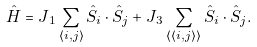<formula> <loc_0><loc_0><loc_500><loc_500>\hat { H } = J { _ { 1 } } \sum _ { \langle i , j \rangle } \hat { S } _ { i } \cdot \hat { S } _ { j } + J { _ { 3 } } \sum _ { \langle \langle i , j \rangle \rangle } \hat { S } _ { i } \cdot \hat { S } _ { j } .</formula> 